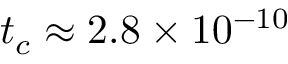<formula> <loc_0><loc_0><loc_500><loc_500>t _ { c } \approx 2 . 8 \times 1 0 ^ { - 1 0 }</formula> 